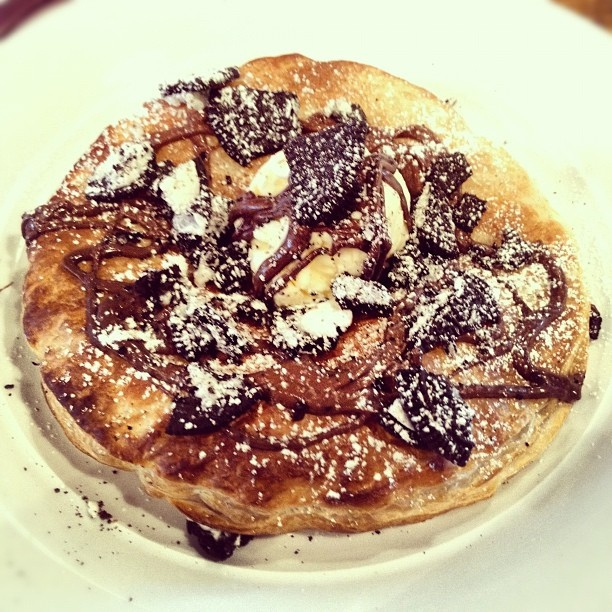Describe the objects in this image and their specific colors. I can see a pizza in lightgray, maroon, khaki, beige, and black tones in this image. 